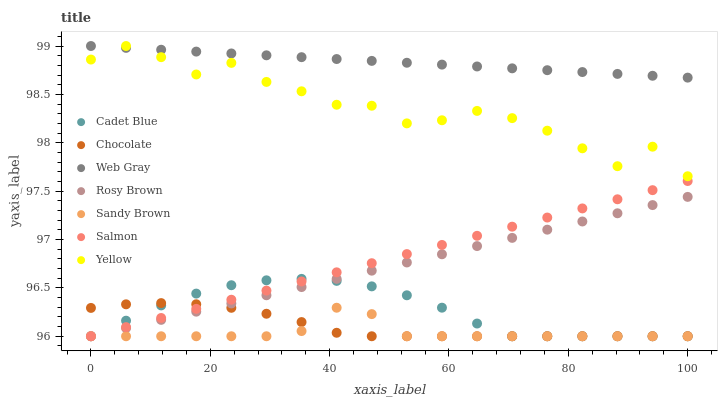Does Sandy Brown have the minimum area under the curve?
Answer yes or no. Yes. Does Web Gray have the maximum area under the curve?
Answer yes or no. Yes. Does Rosy Brown have the minimum area under the curve?
Answer yes or no. No. Does Rosy Brown have the maximum area under the curve?
Answer yes or no. No. Is Web Gray the smoothest?
Answer yes or no. Yes. Is Yellow the roughest?
Answer yes or no. Yes. Is Rosy Brown the smoothest?
Answer yes or no. No. Is Rosy Brown the roughest?
Answer yes or no. No. Does Cadet Blue have the lowest value?
Answer yes or no. Yes. Does Yellow have the lowest value?
Answer yes or no. No. Does Web Gray have the highest value?
Answer yes or no. Yes. Does Rosy Brown have the highest value?
Answer yes or no. No. Is Rosy Brown less than Web Gray?
Answer yes or no. Yes. Is Yellow greater than Chocolate?
Answer yes or no. Yes. Does Sandy Brown intersect Chocolate?
Answer yes or no. Yes. Is Sandy Brown less than Chocolate?
Answer yes or no. No. Is Sandy Brown greater than Chocolate?
Answer yes or no. No. Does Rosy Brown intersect Web Gray?
Answer yes or no. No. 